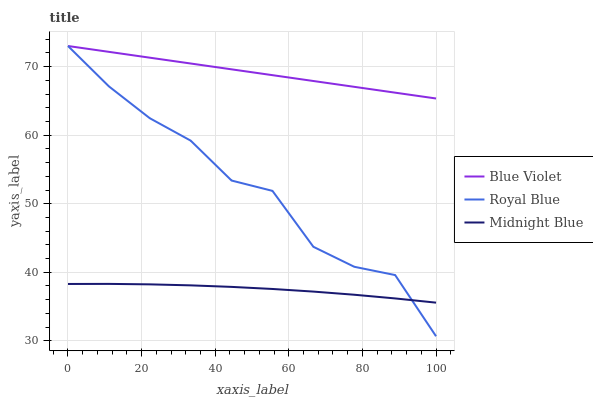Does Midnight Blue have the minimum area under the curve?
Answer yes or no. Yes. Does Blue Violet have the maximum area under the curve?
Answer yes or no. Yes. Does Blue Violet have the minimum area under the curve?
Answer yes or no. No. Does Midnight Blue have the maximum area under the curve?
Answer yes or no. No. Is Blue Violet the smoothest?
Answer yes or no. Yes. Is Royal Blue the roughest?
Answer yes or no. Yes. Is Midnight Blue the smoothest?
Answer yes or no. No. Is Midnight Blue the roughest?
Answer yes or no. No. Does Midnight Blue have the lowest value?
Answer yes or no. No. Does Blue Violet have the highest value?
Answer yes or no. Yes. Does Midnight Blue have the highest value?
Answer yes or no. No. Is Midnight Blue less than Blue Violet?
Answer yes or no. Yes. Is Blue Violet greater than Midnight Blue?
Answer yes or no. Yes. Does Blue Violet intersect Royal Blue?
Answer yes or no. Yes. Is Blue Violet less than Royal Blue?
Answer yes or no. No. Is Blue Violet greater than Royal Blue?
Answer yes or no. No. Does Midnight Blue intersect Blue Violet?
Answer yes or no. No. 